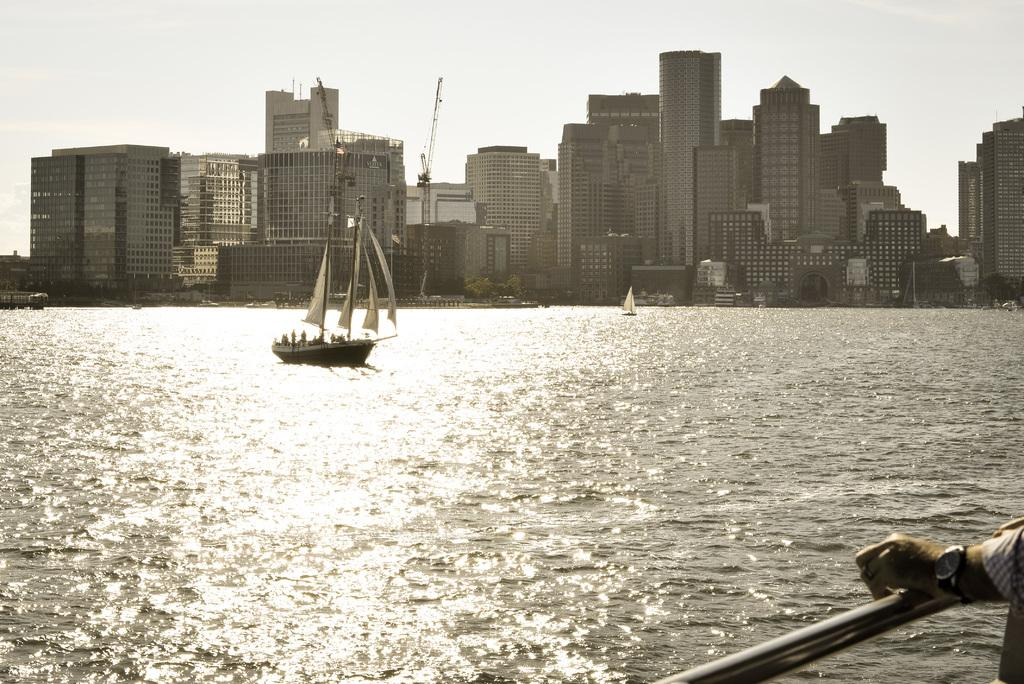What is the main subject of the image? The main subject of the image is a boat. Where is the boat located? The boat is on the water. What can be seen in the background of the image? There are buildings in the background of the image. What is the color of the sky in the image? The sky is blue in color. What type of reaction can be seen from the mailbox in the image? There is no mailbox present in the image, so it is not possible to determine any reaction from it. 